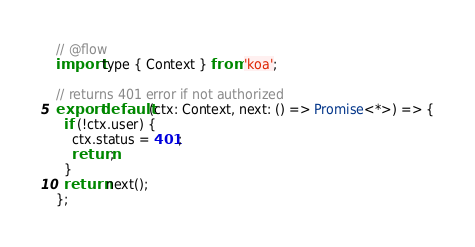<code> <loc_0><loc_0><loc_500><loc_500><_JavaScript_>// @flow
import type { Context } from 'koa';

// returns 401 error if not authorized
export default (ctx: Context, next: () => Promise<*>) => {
  if (!ctx.user) {
    ctx.status = 401;
    return;
  }
  return next();
};
</code> 